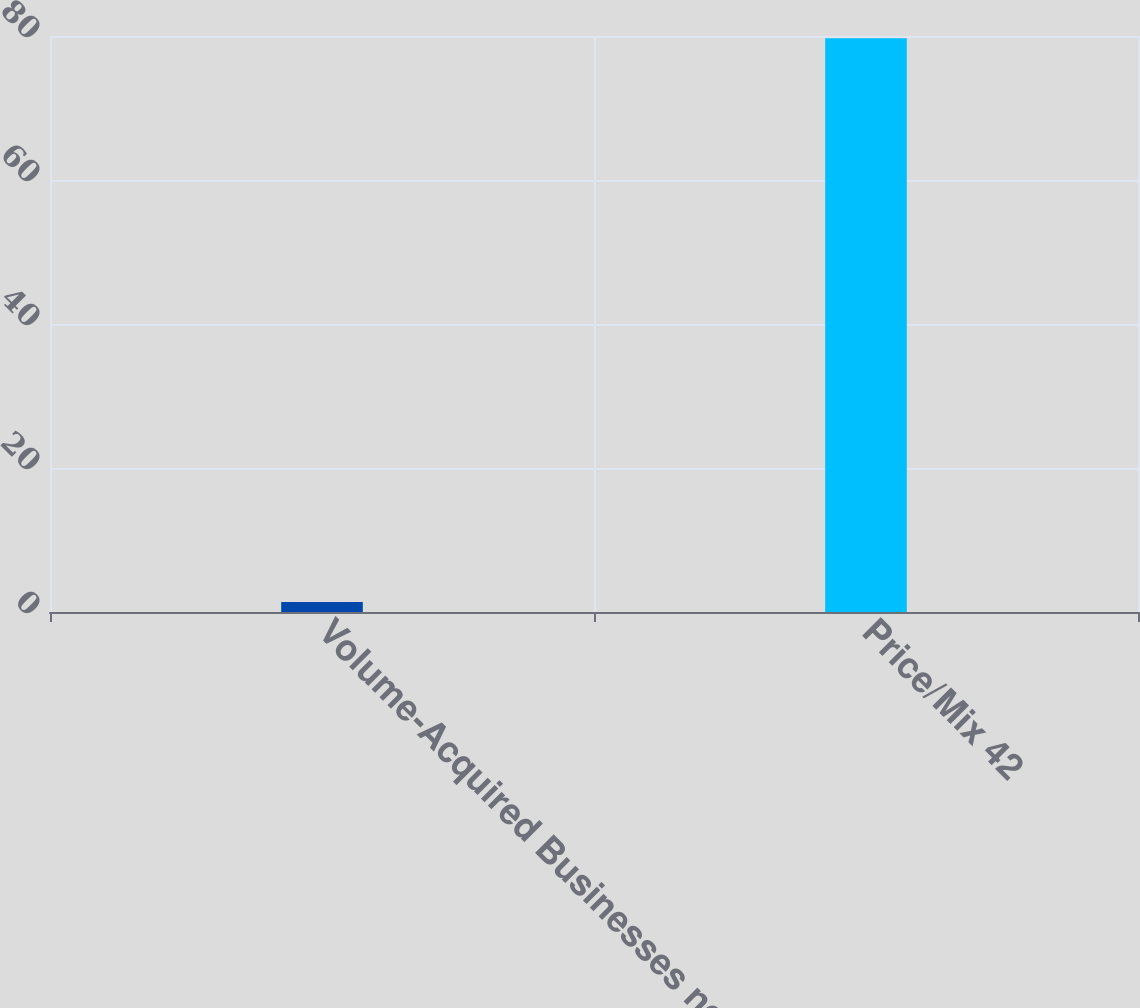Convert chart to OTSL. <chart><loc_0><loc_0><loc_500><loc_500><bar_chart><fcel>Volume-Acquired Businesses net<fcel>Price/Mix 42<nl><fcel>1.4<fcel>79.7<nl></chart> 